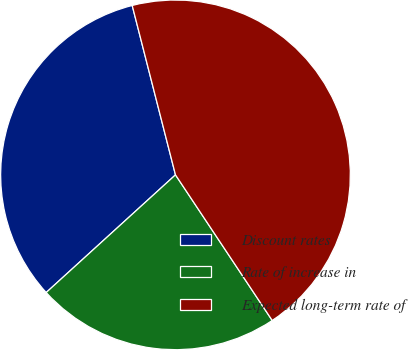Convert chart to OTSL. <chart><loc_0><loc_0><loc_500><loc_500><pie_chart><fcel>Discount rates<fcel>Rate of increase in<fcel>Expected long-term rate of<nl><fcel>32.77%<fcel>22.58%<fcel>44.65%<nl></chart> 